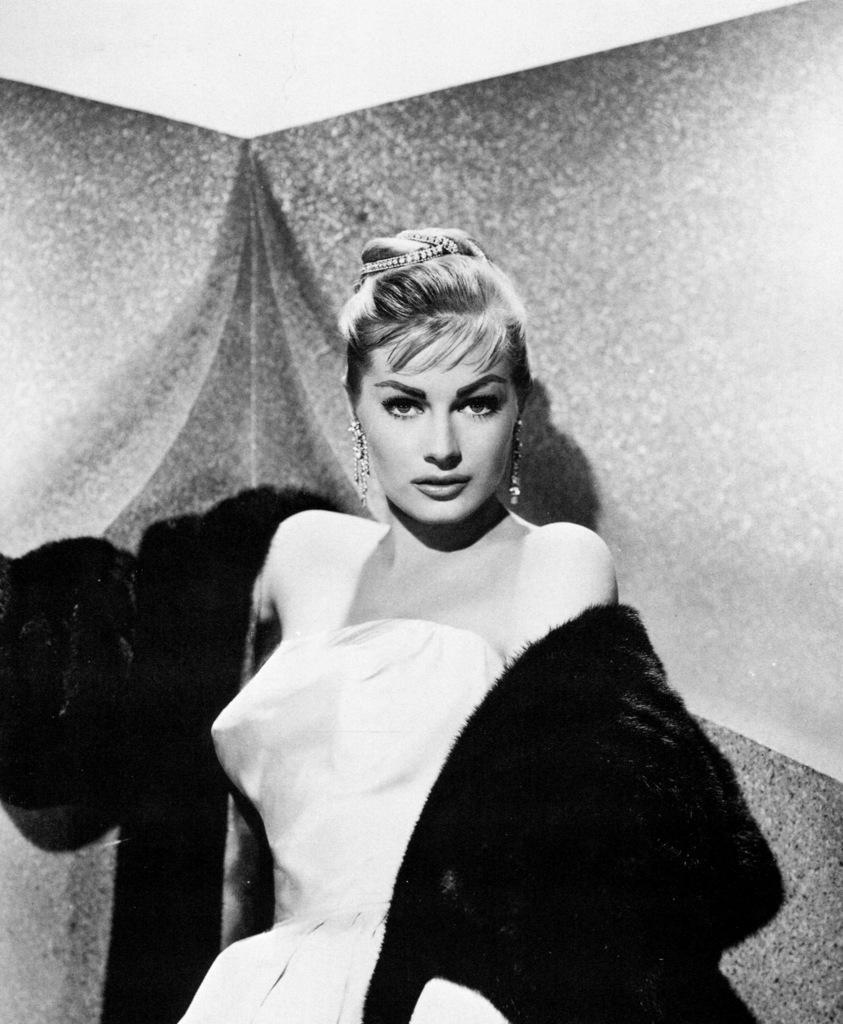What is the color scheme of the image? The image is black and white. Can you describe the main subject of the image? There is a woman in the image. What type of bubbles can be seen in the woman's glass in the image? There are no bubbles or glasses present in the image, as it is a black and white image featuring a woman. 